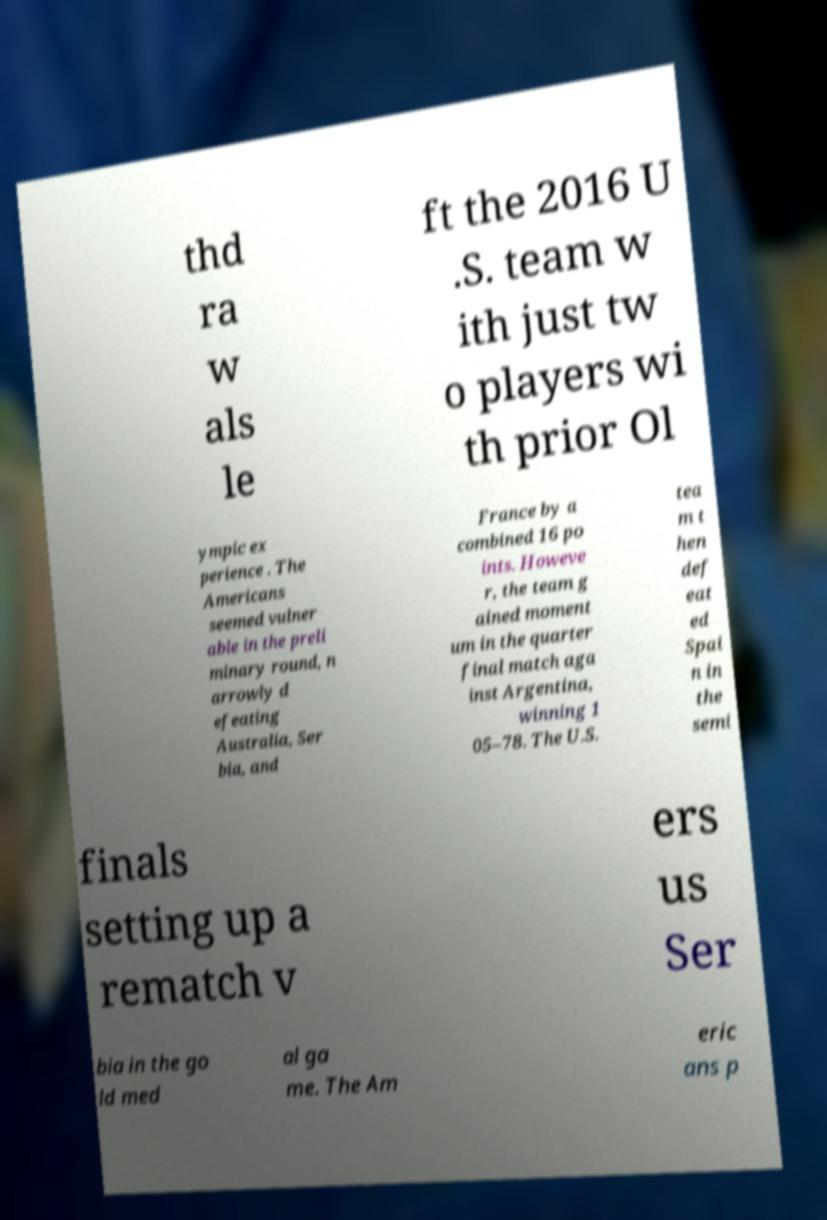Can you read and provide the text displayed in the image?This photo seems to have some interesting text. Can you extract and type it out for me? thd ra w als le ft the 2016 U .S. team w ith just tw o players wi th prior Ol ympic ex perience . The Americans seemed vulner able in the preli minary round, n arrowly d efeating Australia, Ser bia, and France by a combined 16 po ints. Howeve r, the team g ained moment um in the quarter final match aga inst Argentina, winning 1 05–78. The U.S. tea m t hen def eat ed Spai n in the semi finals setting up a rematch v ers us Ser bia in the go ld med al ga me. The Am eric ans p 